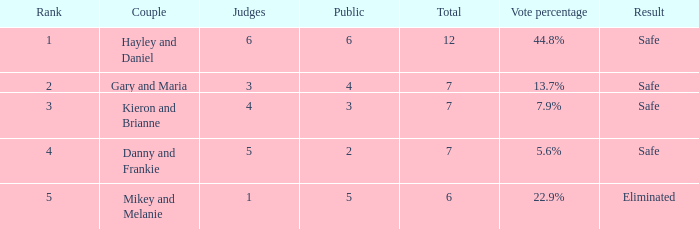When the vote percentage reached 44.8%, what was the entire count? 1.0. 